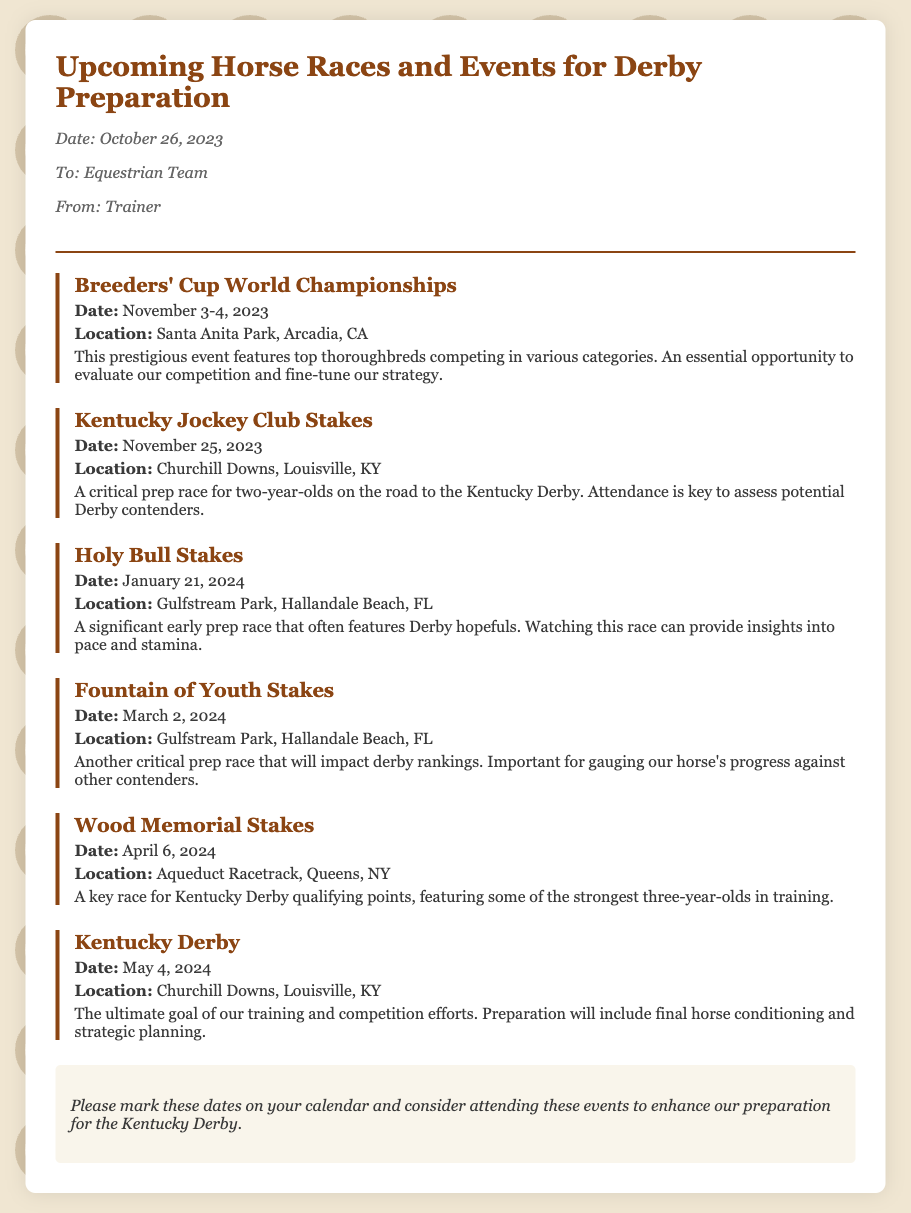What is the date of the Breeders' Cup World Championships? The date of the Breeders' Cup World Championships is mentioned in the event details as November 3-4, 2023.
Answer: November 3-4, 2023 Where is the Kentucky Jockey Club Stakes held? The location is provided in the event details, which states it takes place at Churchill Downs, Louisville, KY.
Answer: Churchill Downs, Louisville, KY What is the significance of the Holy Bull Stakes? The memo describes the Holy Bull Stakes as a significant early prep race for potential Derby contenders.
Answer: Significant early prep race When is the Kentucky Derby scheduled? The schedule for the Kentucky Derby is specified in the document as May 4, 2024.
Answer: May 4, 2024 How many key events are listed before the Kentucky Derby? There are five events listed before the Kentucky Derby to prepare for it.
Answer: Five What is the primary goal mentioned in the conclusion? The conclusion emphasizes that the ultimate goal of training and competition efforts is the Kentucky Derby.
Answer: Kentucky Derby Which event has the earliest date in the schedule? The earliest date mentioned is for the Breeders' Cup World Championships on November 3-4, 2023.
Answer: November 3-4, 2023 What type of document is this memo categorized as? The document is categorized as a memo outlining upcoming horse races and events for Derby preparation.
Answer: Memo Which event takes place in April? The event taking place in April is the Wood Memorial Stakes on April 6, 2024.
Answer: Wood Memorial Stakes 